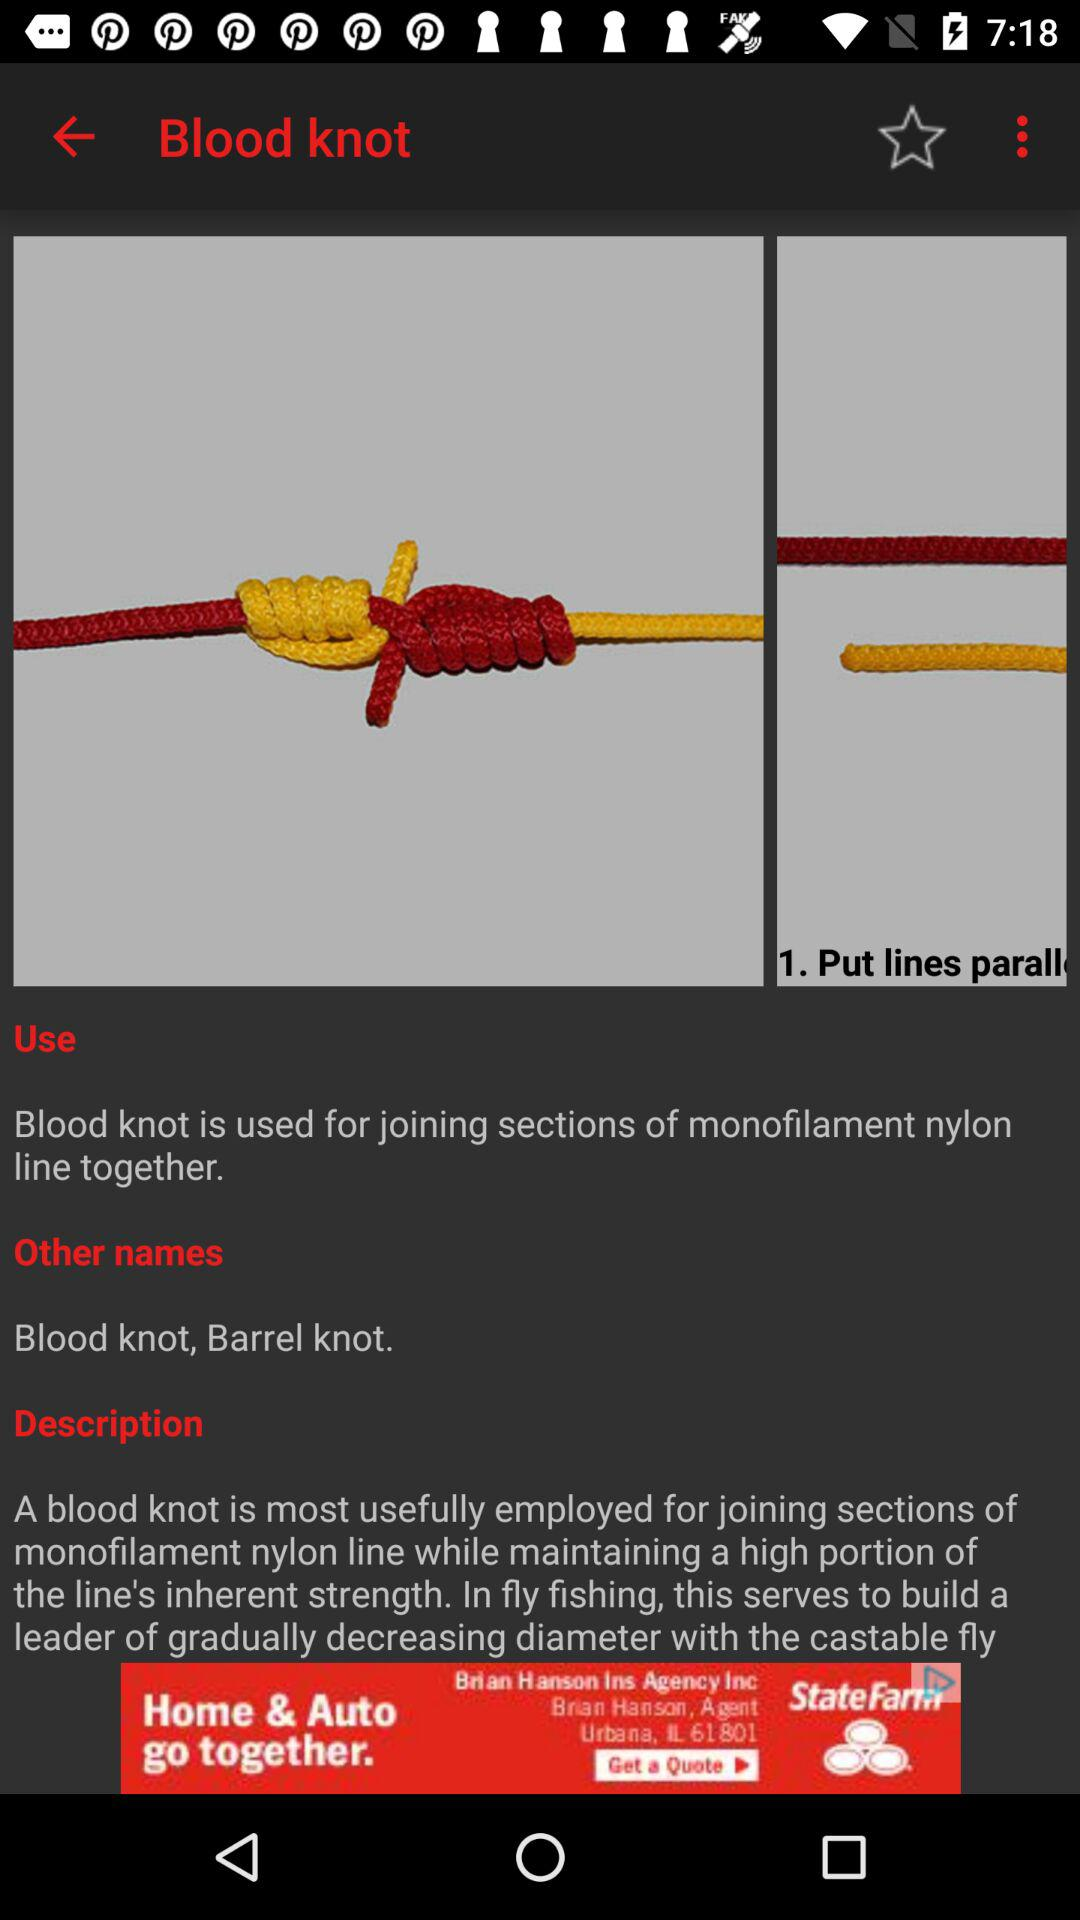What is the given description? The given description is "A blood knot is most usefully employed for joining sections of monofilament nylon line while maintaining a high portion of the line's inherent strength. In fly fishing, this serves to build a leader of gradually decreasing diameter with the castable fly". 